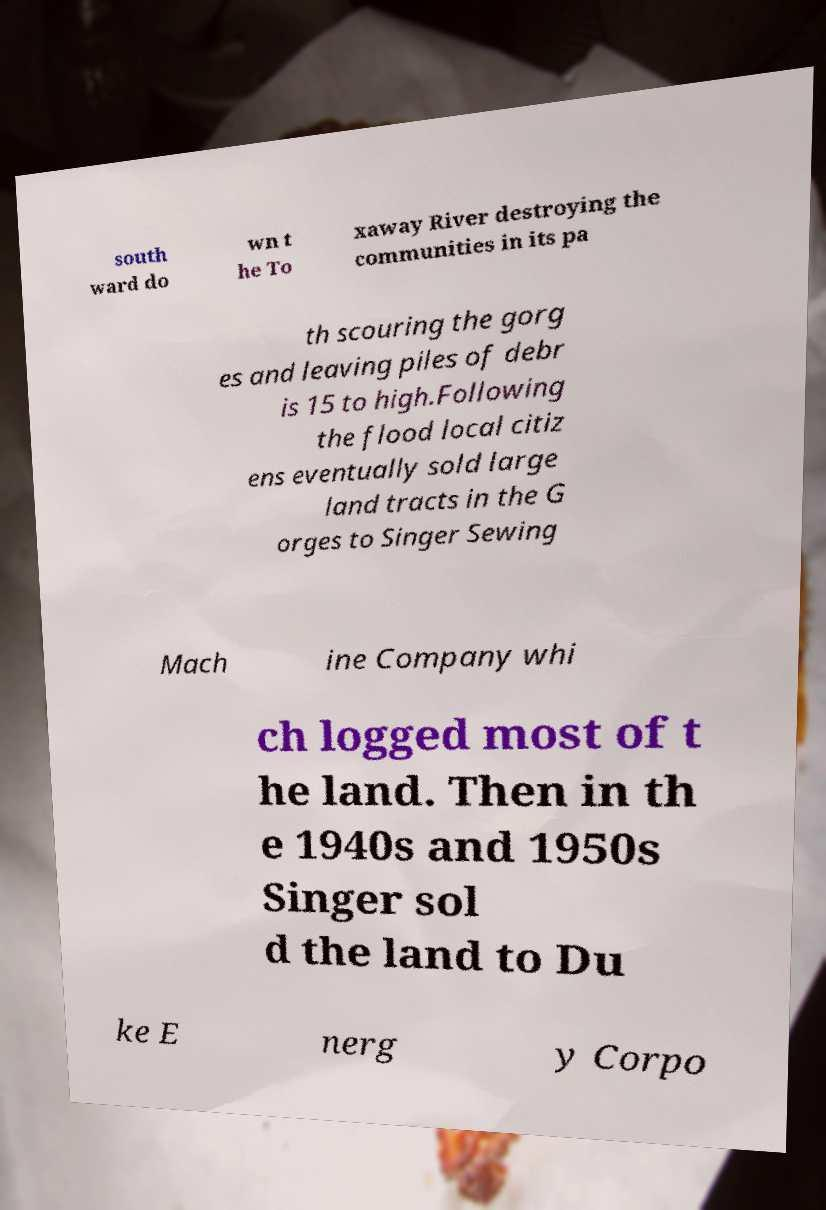Could you assist in decoding the text presented in this image and type it out clearly? south ward do wn t he To xaway River destroying the communities in its pa th scouring the gorg es and leaving piles of debr is 15 to high.Following the flood local citiz ens eventually sold large land tracts in the G orges to Singer Sewing Mach ine Company whi ch logged most of t he land. Then in th e 1940s and 1950s Singer sol d the land to Du ke E nerg y Corpo 